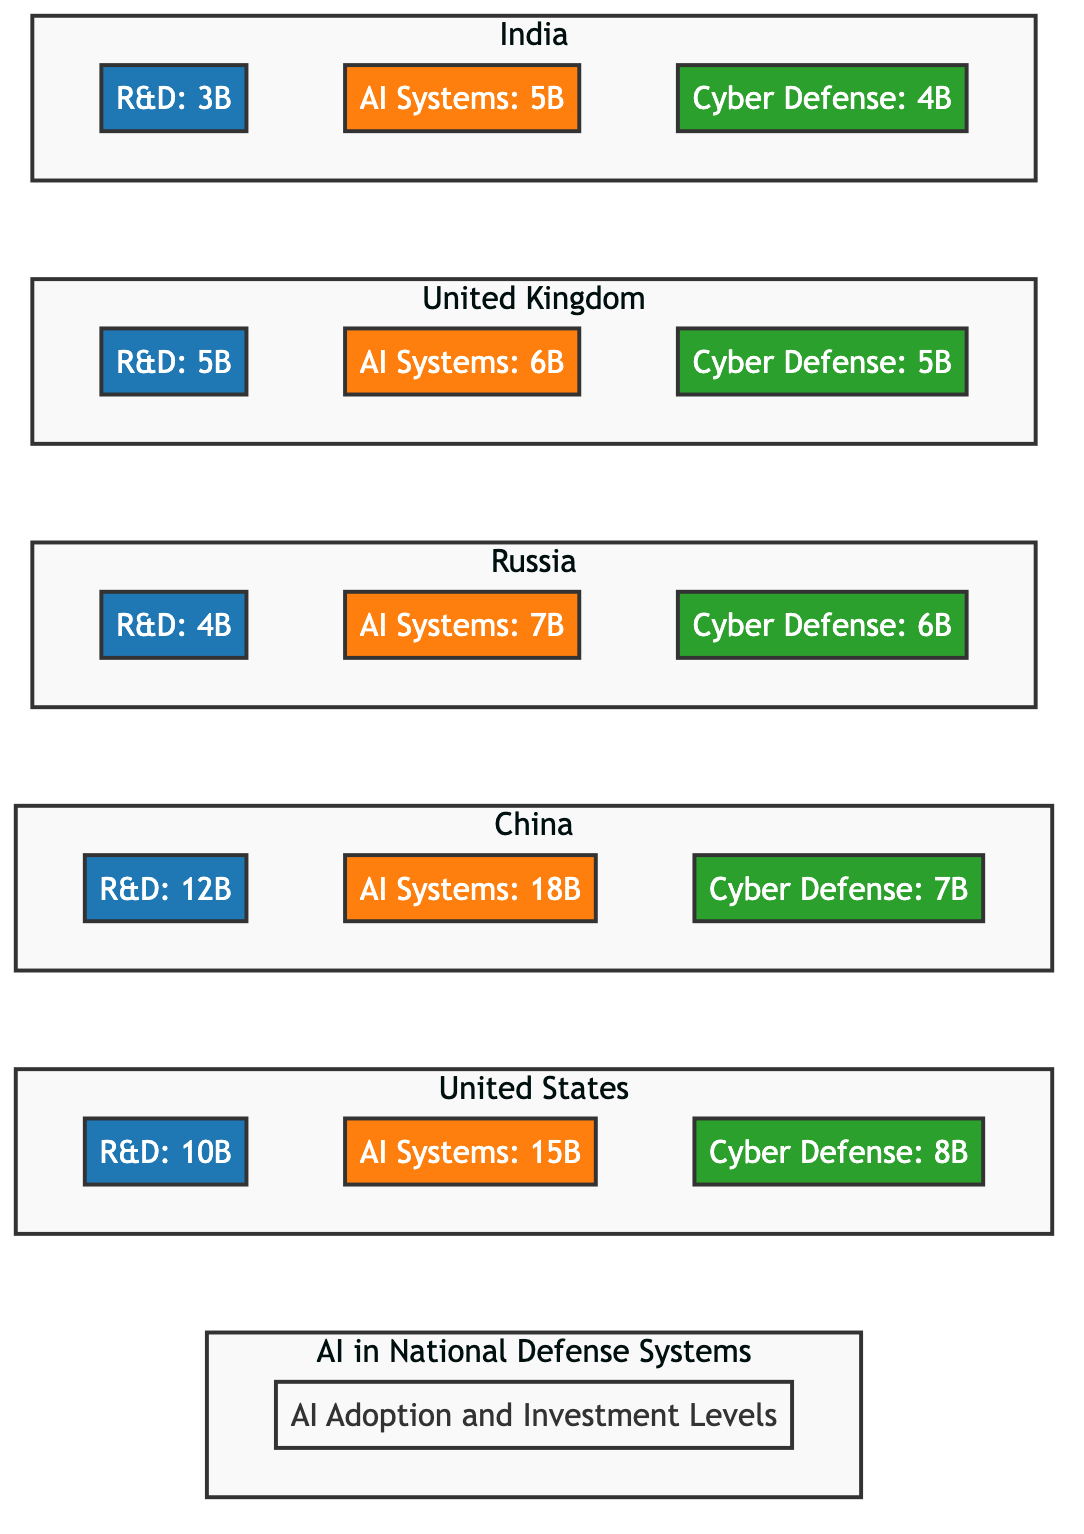What is the total R&D investment of the United States? The diagram lists the investment for R&D in the United States as 10B.
Answer: 10B Which country has the highest investment in AI systems? By comparing the values for AI Systems in the diagram, China has the highest investment at 18B.
Answer: China What is the Cyber Defense investment level for India? The diagram shows India's investment in Cyber Defense as 4B.
Answer: 4B How much more does China invest in AI systems compared to Russia? China invests 18B in AI Systems while Russia invests 7B. The difference is calculated as 18B - 7B = 11B.
Answer: 11B Which nation has the least investment in R&D? By comparing R&D investments in the diagram, India has the least at 3B.
Answer: India If we sum all the R&D investments, what is the total? Adding all R&D investments: 10B (US) + 12B (China) + 4B (Russia) + 5B (UK) + 3B (India) gives us a total of 34B.
Answer: 34B How does the Cyber Defense investment of the United Kingdom compare to that of China? The UK invests 5B in Cyber Defense while China invests 7B. UK has 2B less than China, as calculated: 7B - 5B = 2B.
Answer: UK has 2B less What is the combined investment in AI systems for the United States and the United Kingdom? The investments for AI systems are 15B (US) and 6B (UK). Summing these gives 15B + 6B = 21B.
Answer: 21B List the investments related to Cyber Defense in descending order. The investments in Cyber Defense are as follows: China 7B, Russia 6B, UK 5B, India 4B, and US 8B. Arranging these from highest to lowest gives: China, US, Russia, UK, India.
Answer: China, US, Russia, UK, India 